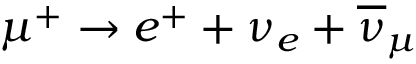Convert formula to latex. <formula><loc_0><loc_0><loc_500><loc_500>\mu ^ { + } \rightarrow e ^ { + } + \nu _ { e } + \overline { \nu } _ { \mu }</formula> 